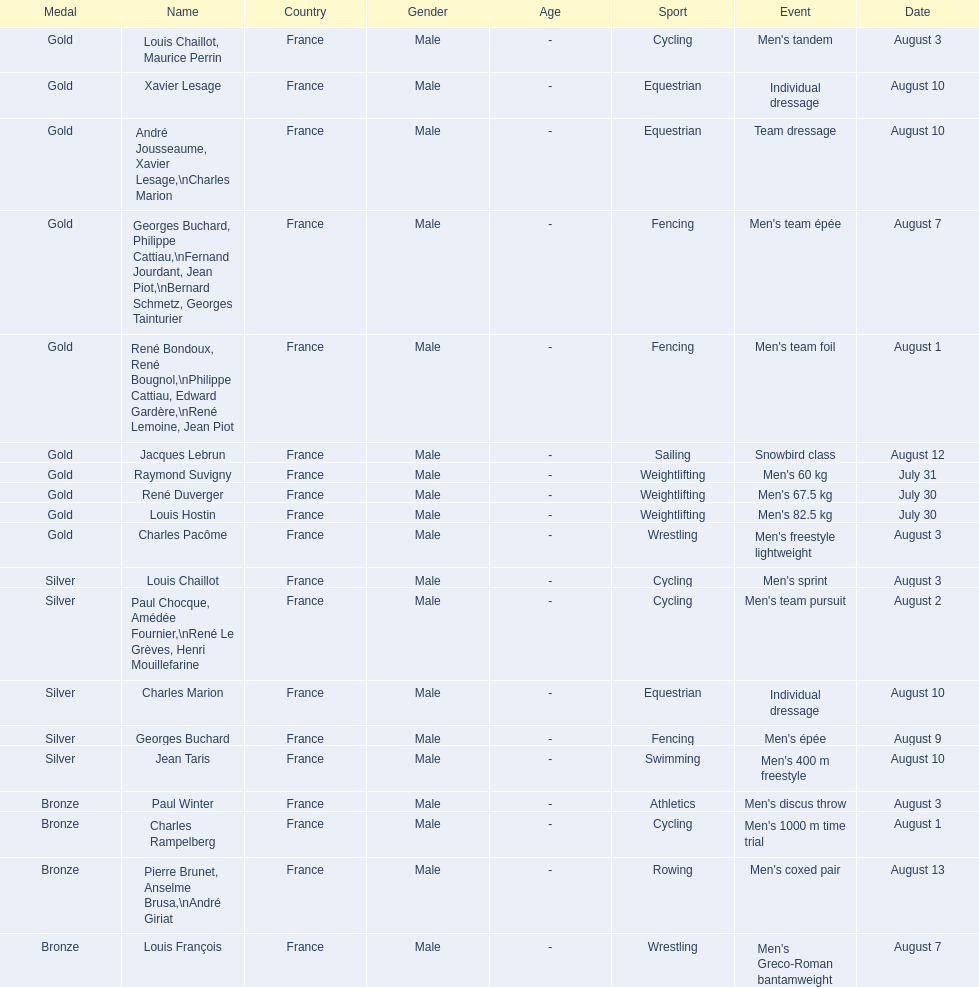Louis chaillot won a gold medal for cycling and a silver medal for what sport? Cycling. 